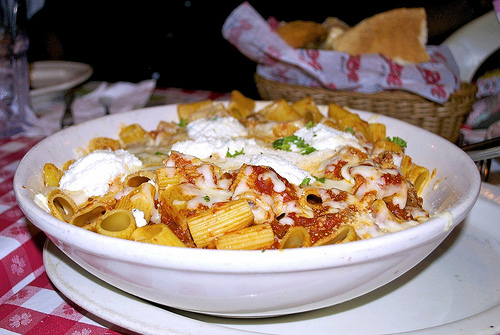<image>
Is the pasta under the bread? No. The pasta is not positioned under the bread. The vertical relationship between these objects is different. Is there a pasta in the basket? No. The pasta is not contained within the basket. These objects have a different spatial relationship. Is there a cheese on the rigatoni? Yes. Looking at the image, I can see the cheese is positioned on top of the rigatoni, with the rigatoni providing support. Where is the pasta in relation to the basket? Is it on the basket? No. The pasta is not positioned on the basket. They may be near each other, but the pasta is not supported by or resting on top of the basket. 